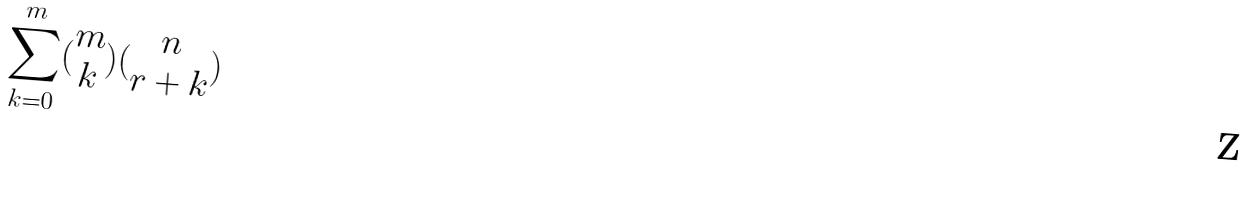Convert formula to latex. <formula><loc_0><loc_0><loc_500><loc_500>\sum _ { k = 0 } ^ { m } ( \begin{matrix} m \\ k \end{matrix} ) ( \begin{matrix} n \\ r + k \end{matrix} )</formula> 